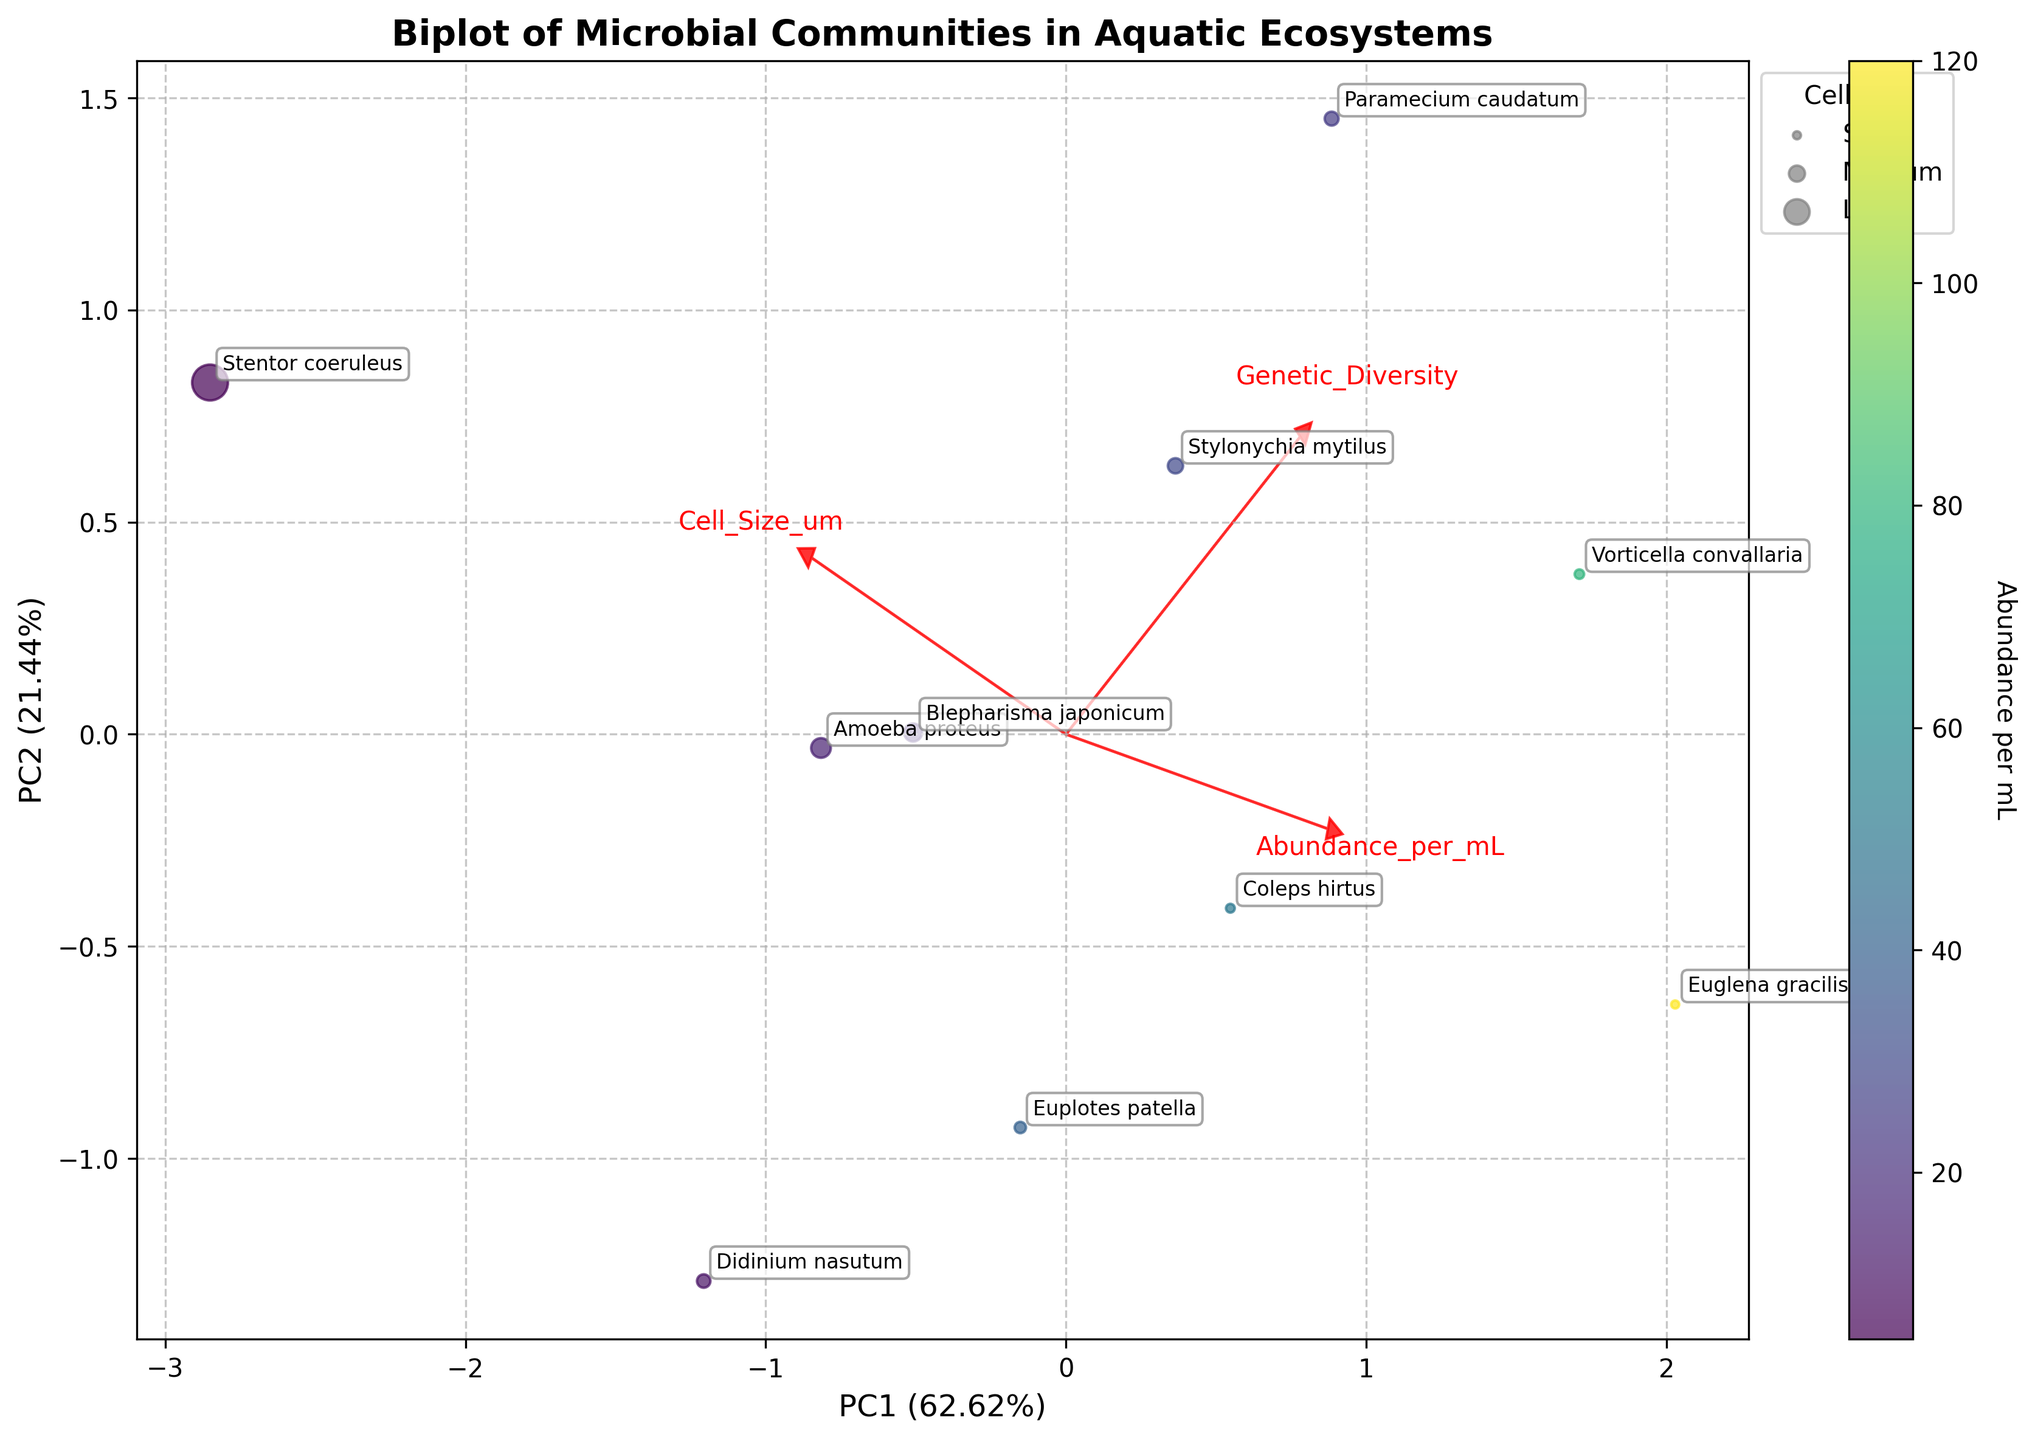What is the title of the biplot? The title is the text at the top of the plot. It reads "Biplot of Microbial Communities in Aquatic Ecosystems".
Answer: Biplot of Microbial Communities in Aquatic Ecosystems What do the axes PC1 and PC2 represent? The plot has two main axes labeled PC1 and PC2, which represent the first two principal components derived from the PCA analysis of the standardized features.
Answer: The first two principal components What is indicated by the color gradient in the scatter plot? The color gradient refers to the color coding of the data points, indicated by the color bar labeled "Abundance per mL".
Answer: Abundance per mL Which species has the largest cell size, and how can you tell? The species "Stentor coeruleus" has the largest marker size. Marker size in the plot reflects cell size, and "Stentor coeruleus" has the largest marker.
Answer: Stentor coeruleus How do the loading vectors relate to the features Genetic Diversity and Cell Size um? The loading vectors show the orientation and magnitude direction of the original variables. For example, the arrows for Genetic Diversity and Cell Size um indicate the contribution and correlation of these features to the principal components.
Answer: They indicate contribution and correlation Which species appears to have the highest genetic diversity? By looking at the position of the data points along the respective axis, the species "Paramecium caudatum" is located in the upper-right quadrant aligning closely with the Genetic Diversity vector.
Answer: Paramecium caudatum Compare the abundance per mL for "Euglena gracilis" and "Didinium nasutum”. Which is higher? The scatter points' colors indicate abundance per mL. "Euglena gracilis" is in shades of bright yellow, while "Didinium nasutum" is darker, indicating "Euglena gracilis" has higher abundance.
Answer: Euglena gracilis Which ecosystem has the highest cell size per microorganism, and how does it compare to the lowest? By observing the scatter plot points, "Stentor coeruleus" (Slow-moving river) has the largest markers, indicating the highest cell size, while "Euglena gracilis" (Eutrophic lake) has one of the smallest markers.
Answer: Slow-moving river has the highest, Eutrophic lake has the lowest What percentage variance is explained by the first principal component (PC1)? The x-axis label of the biplot provides this information. The label for PC1 includes the explained variance, which is a percentage.
Answer: It explains 59.7% variance Is there any clear clustering pattern suggesting common traits among certain species in specific ecosystems? Examining the plot, species from different aquatic environments spread out across both components. There are no clear visual clusters suggesting distinct common traits among them by just looking at PC1 and PC2.
Answer: No clear clustering pattern 